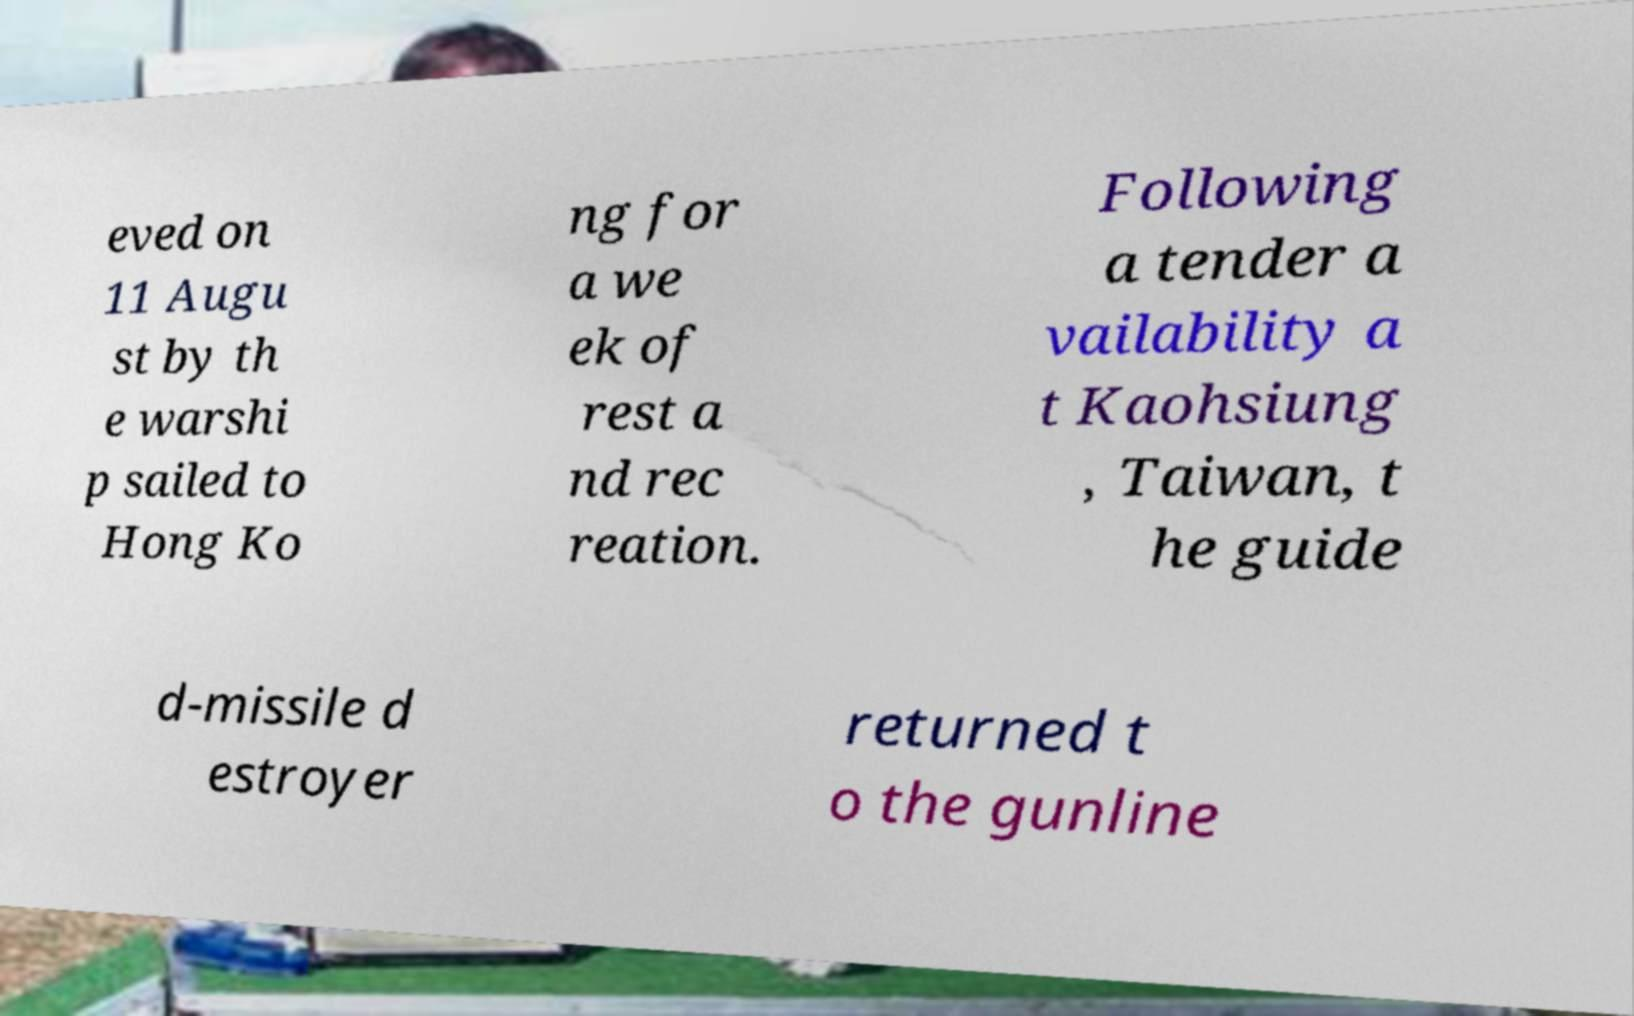Please identify and transcribe the text found in this image. eved on 11 Augu st by th e warshi p sailed to Hong Ko ng for a we ek of rest a nd rec reation. Following a tender a vailability a t Kaohsiung , Taiwan, t he guide d-missile d estroyer returned t o the gunline 